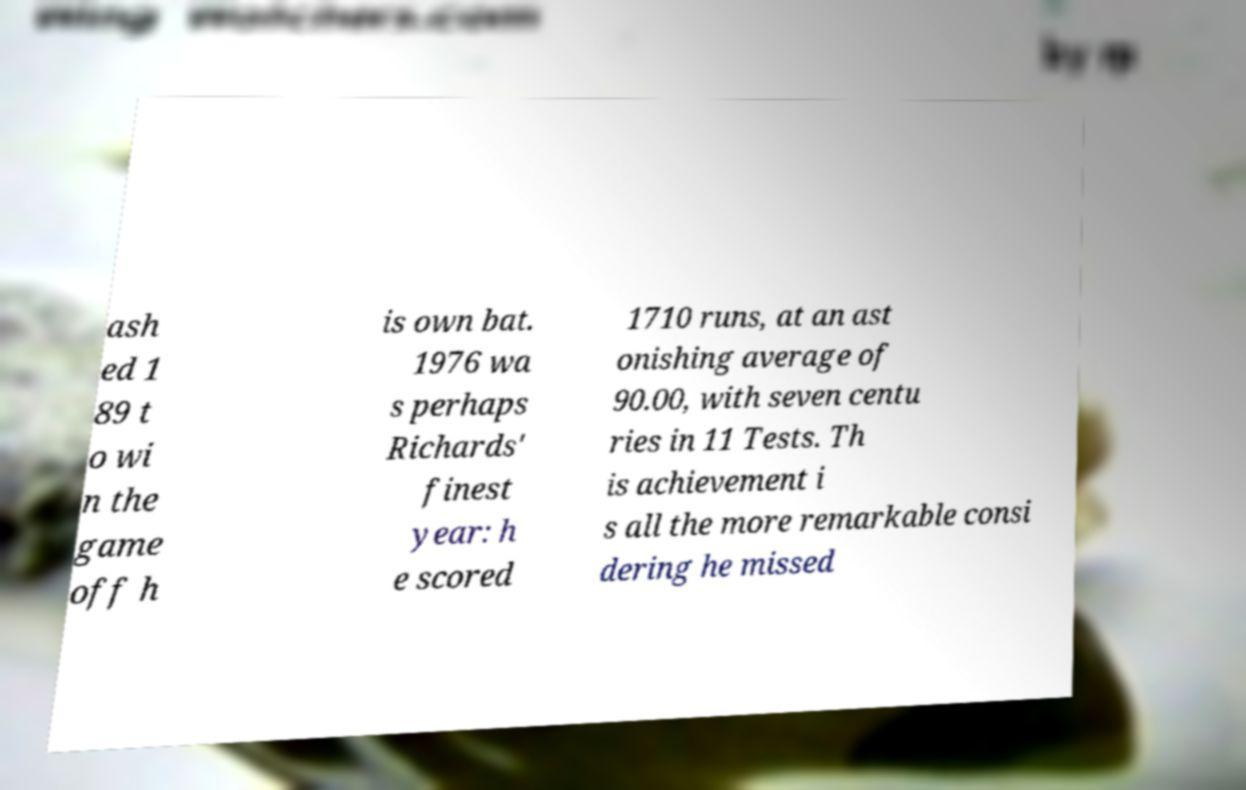Please identify and transcribe the text found in this image. ash ed 1 89 t o wi n the game off h is own bat. 1976 wa s perhaps Richards' finest year: h e scored 1710 runs, at an ast onishing average of 90.00, with seven centu ries in 11 Tests. Th is achievement i s all the more remarkable consi dering he missed 